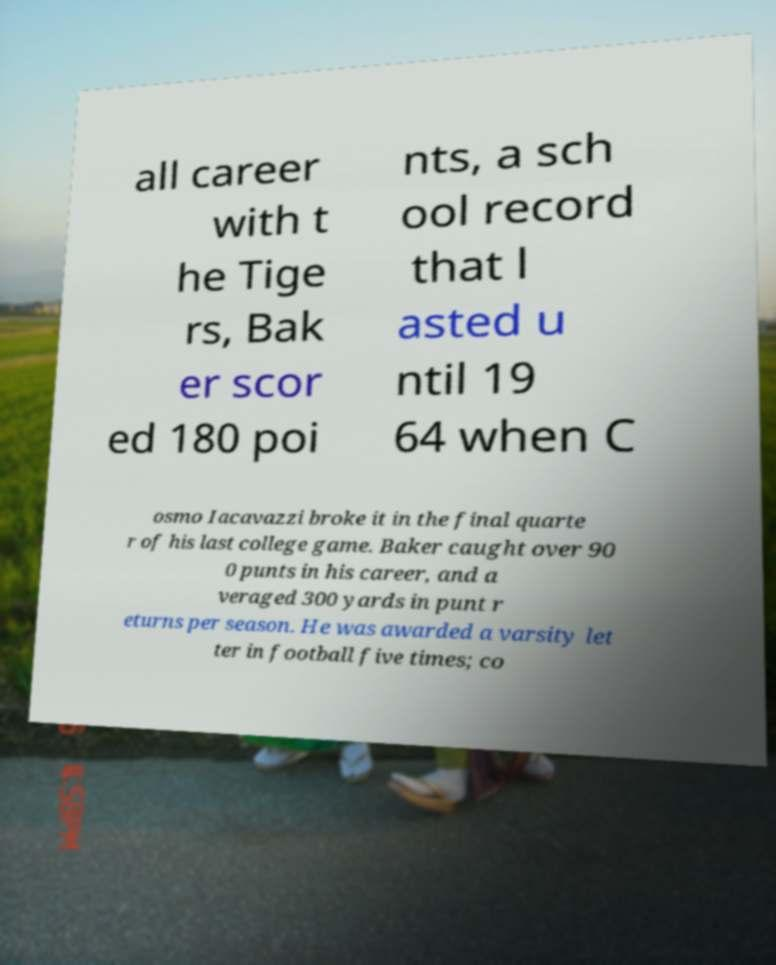Please identify and transcribe the text found in this image. all career with t he Tige rs, Bak er scor ed 180 poi nts, a sch ool record that l asted u ntil 19 64 when C osmo Iacavazzi broke it in the final quarte r of his last college game. Baker caught over 90 0 punts in his career, and a veraged 300 yards in punt r eturns per season. He was awarded a varsity let ter in football five times; co 